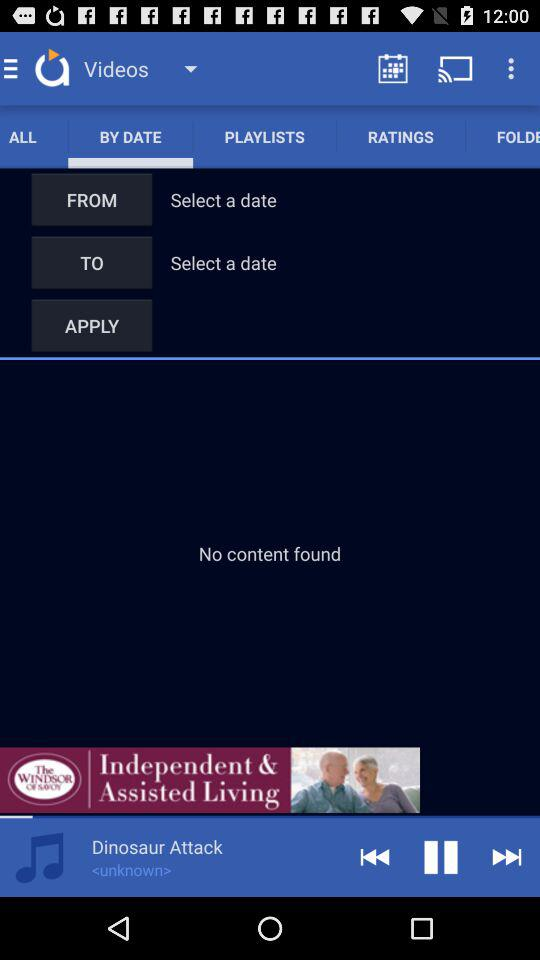Which date is selected for "FROM"?
When the provided information is insufficient, respond with <no answer>. <no answer> 